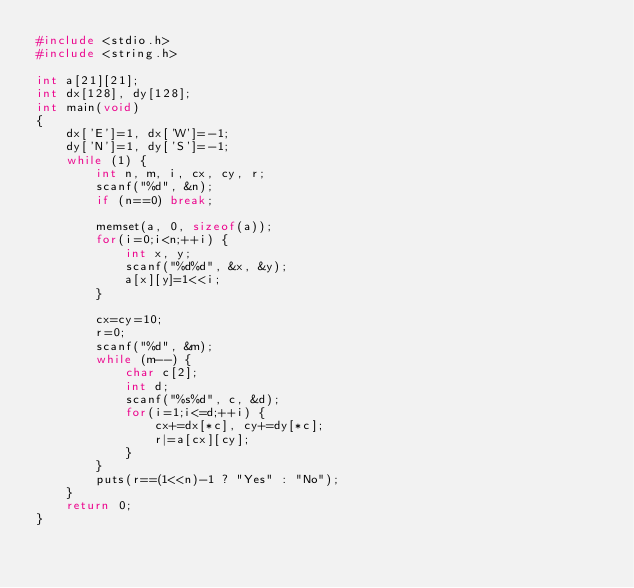Convert code to text. <code><loc_0><loc_0><loc_500><loc_500><_C_>#include <stdio.h>
#include <string.h>

int a[21][21];
int dx[128], dy[128];
int main(void)
{
    dx['E']=1, dx['W']=-1;
    dy['N']=1, dy['S']=-1;
    while (1) {
        int n, m, i, cx, cy, r;
        scanf("%d", &n);
        if (n==0) break;

        memset(a, 0, sizeof(a));
        for(i=0;i<n;++i) {
            int x, y;
            scanf("%d%d", &x, &y);
            a[x][y]=1<<i;
        }

        cx=cy=10;
        r=0;
        scanf("%d", &m);
        while (m--) {
            char c[2];
            int d;
            scanf("%s%d", c, &d);
            for(i=1;i<=d;++i) {
                cx+=dx[*c], cy+=dy[*c];
                r|=a[cx][cy];
            }
        }
        puts(r==(1<<n)-1 ? "Yes" : "No");
    }
    return 0;
}</code> 